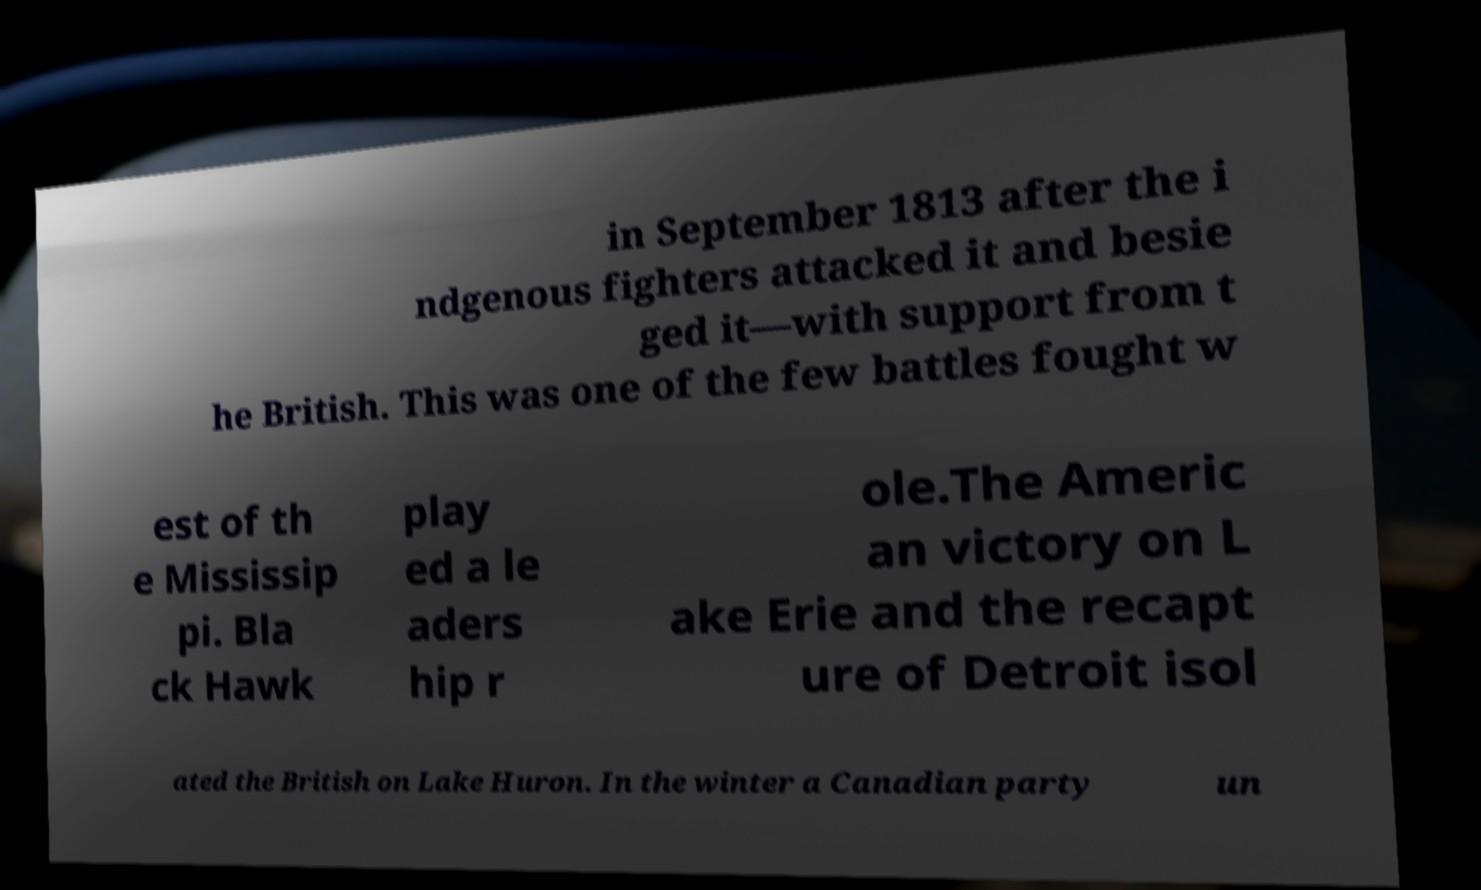Please identify and transcribe the text found in this image. in September 1813 after the i ndgenous fighters attacked it and besie ged it—with support from t he British. This was one of the few battles fought w est of th e Mississip pi. Bla ck Hawk play ed a le aders hip r ole.The Americ an victory on L ake Erie and the recapt ure of Detroit isol ated the British on Lake Huron. In the winter a Canadian party un 